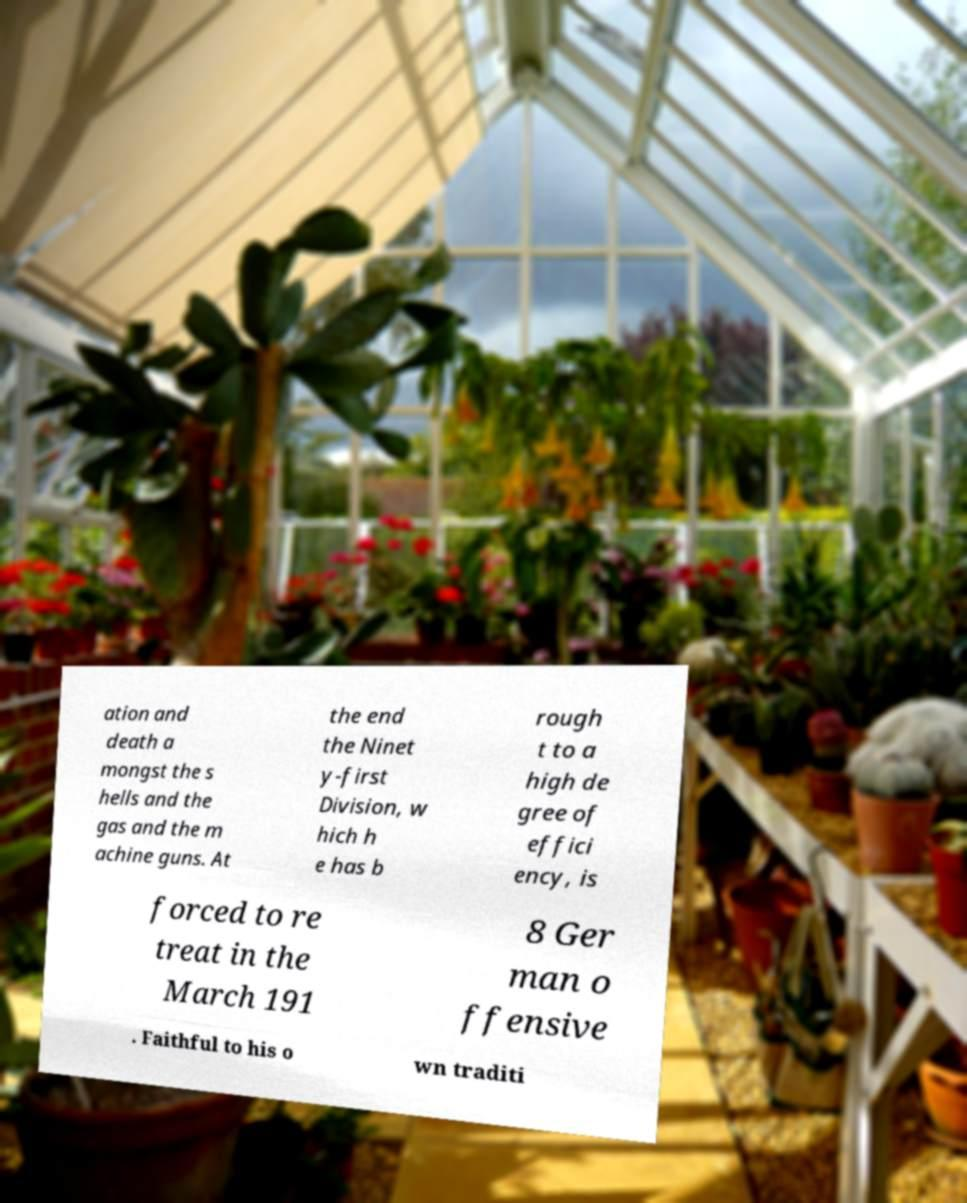Please identify and transcribe the text found in this image. ation and death a mongst the s hells and the gas and the m achine guns. At the end the Ninet y-first Division, w hich h e has b rough t to a high de gree of effici ency, is forced to re treat in the March 191 8 Ger man o ffensive . Faithful to his o wn traditi 